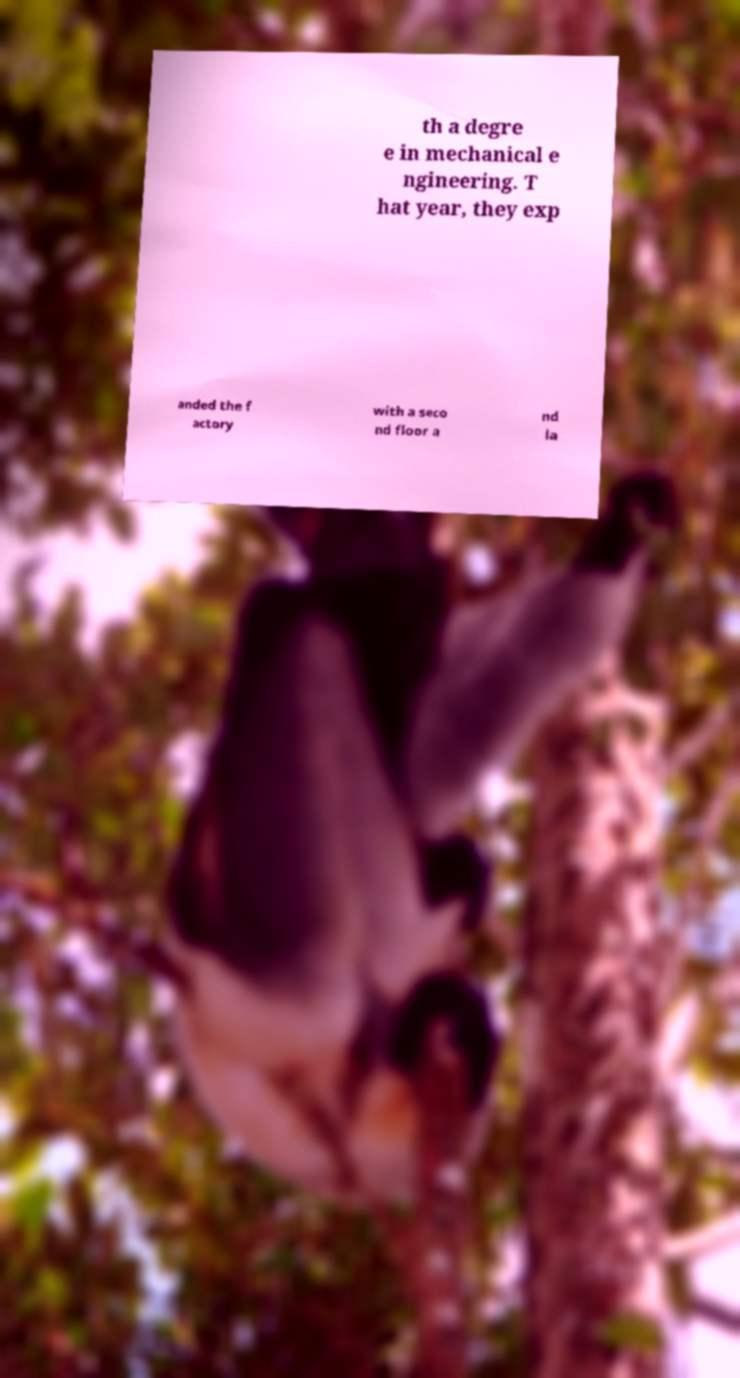Can you accurately transcribe the text from the provided image for me? th a degre e in mechanical e ngineering. T hat year, they exp anded the f actory with a seco nd floor a nd la 